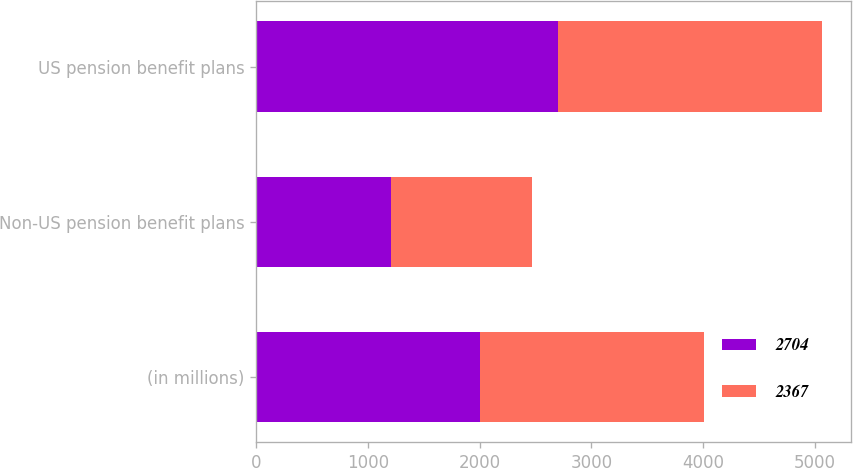Convert chart. <chart><loc_0><loc_0><loc_500><loc_500><stacked_bar_chart><ecel><fcel>(in millions)<fcel>Non-US pension benefit plans<fcel>US pension benefit plans<nl><fcel>2704<fcel>2005<fcel>1210<fcel>2704<nl><fcel>2367<fcel>2004<fcel>1260<fcel>2367<nl></chart> 